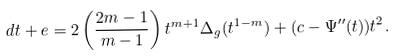<formula> <loc_0><loc_0><loc_500><loc_500>d t + e = 2 \left ( \frac { 2 m - 1 } { m - 1 } \right ) t ^ { m + 1 } \Delta _ { g } ( t ^ { 1 - m } ) + ( c - \Psi ^ { \prime \prime } ( t ) ) t ^ { 2 } .</formula> 